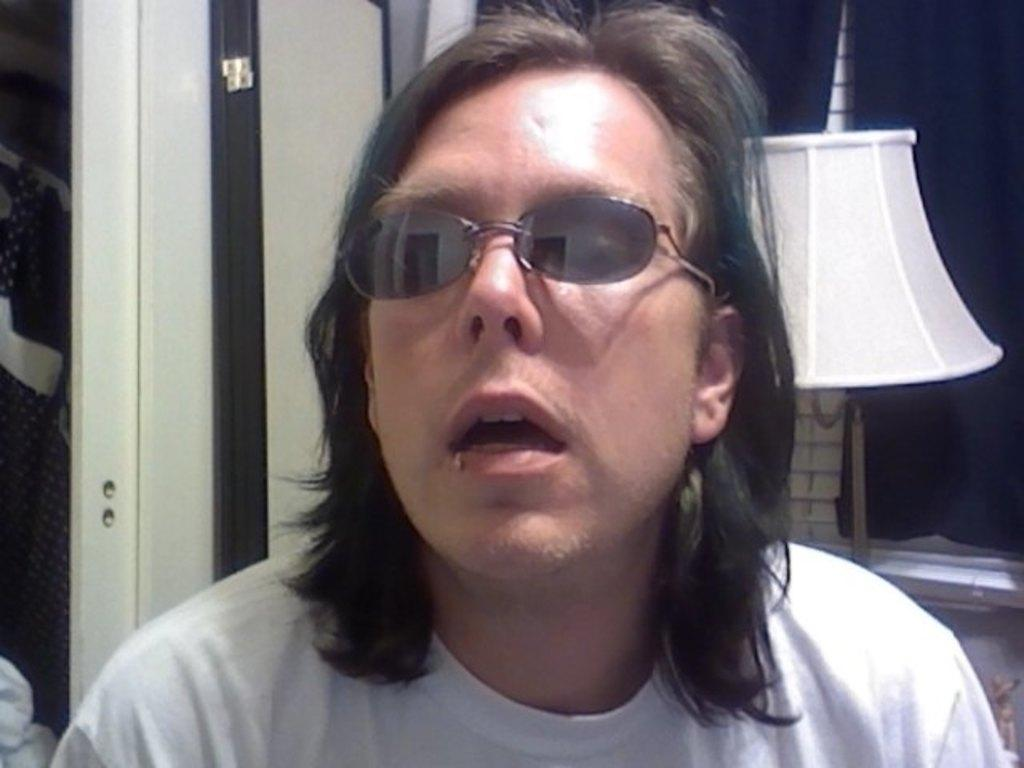Who is the main subject in the image? There is a man in the center of the image. What accessory is the man wearing? The man is wearing glasses. What can be seen in the background of the image? There is a lamp and a door in the background of the image. What color is the man's hair in the image? The provided facts do not mention the man's hair color, so we cannot determine the color of his hair from the image. 